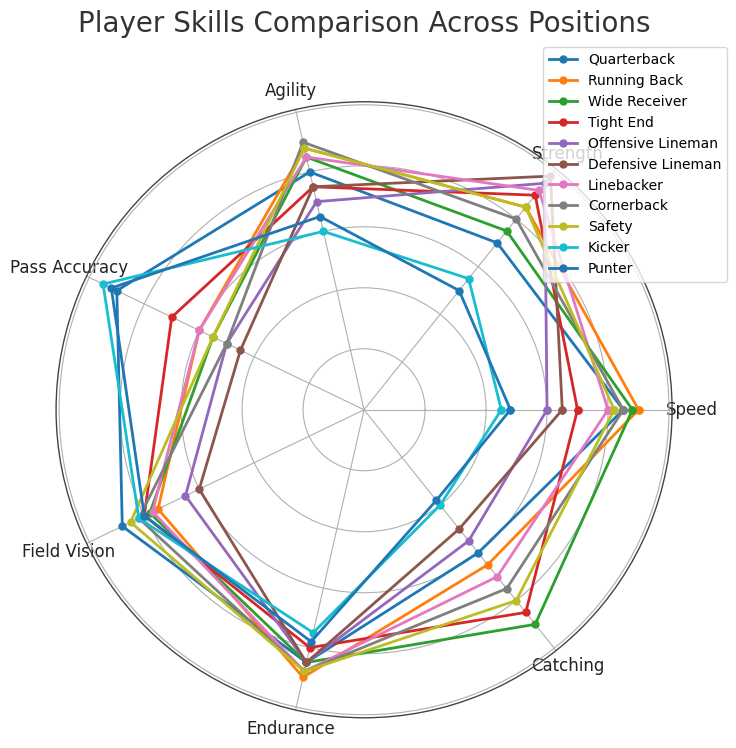Which position has the highest Pass Accuracy? To find the position with the highest Pass Accuracy, look for the position with the highest value in the Pass Accuracy dimension on the radar chart. The Quarterback has a Pass Accuracy of 90, the highest among all positions.
Answer: Quarterback Which position demonstrates the best balance between Endurance and Catching skills? To determine the best balance between Endurance and Catching skills, look for the position where these two metrics are relatively balanced and high. The Tight End has Endurance and Catching values of 80 and 85 respectively, showcasing a good balance.
Answer: Tight End Between Running Back and Wide Receiver, which position is more agile and by how much? Compare the Agility values of the Running Back and Wide Receiver. The Running Back has an Agility of 88, while the Wide Receiver has an Agility of 85. The Running Back is more agile by 3 points.
Answer: Running Back by 3 Which position has the lowest overall skills in Speed and Field Vision combined? Calculate the sum of Speed and Field Vision for each position, and identify the position with the lowest combined score. The Kicker has 45 (Speed) + 82 (Field Vision) = 127, the lowest combined score.
Answer: Kicker Which position ranks highest in Strength but is weakest in Catching? Look for the position with the highest Strength and check its value for Catching. The Defensive Lineman has the highest Strength at 98 but has a lowest Catching value of 50, indicating it is weakest in Catching among the high Strength positions.
Answer: Defensive Lineman What is the average Field Vision across all positions? Sum all Field Vision values across all positions and divide by the number of positions. The total sum is 847, and there are 11 positions. The average is 847/11 = 77.
Answer: 77 Considering Speed and Agility, which position shows the greatest discrepancy between these two skills? Calculate the absolute difference between Speed and Agility for each position. The Offensive Lineman has the greatest discrepancy with Speed 60 and Agility 70, resulting in an absolute difference of 10.
Answer: Offensive Lineman How does the Quarterback compare to the Safety in terms of Pass Accuracy and Agility combined? Sum the Pass Accuracy and Agility for both the Quarterback and the Safety. The Quarterback has 90 (Pass Accuracy) + 80 (Agility) = 170, and the Safety has 55 (Pass Accuracy) + 88 (Agility) = 143. The Quarterback has a combined score of 170 compared to the Safety's 143.
Answer: Quarterback has a higher combined score by 27 Among all positions, which one excels equally in Endurance and Speed? Look for a position where Endurance and Speed values are equal or nearly equal. The Cornerback has Endurance 88 and Speed 85, representing close to equal excellence in both attributes.
Answer: Cornerback Which three positions show the highest versatility across all metrics (Speed, Strength, Agility, Pass Accuracy, Field Vision, Endurance, Catching)? Identify the positions with consistently high values across all metrics by inspecting the radar chart. The Quarterback, Running Back, and Cornerback show the highest versatility, with above-average values in multiple metrics.
Answer: Quarterback, Running Back, Cornerback 